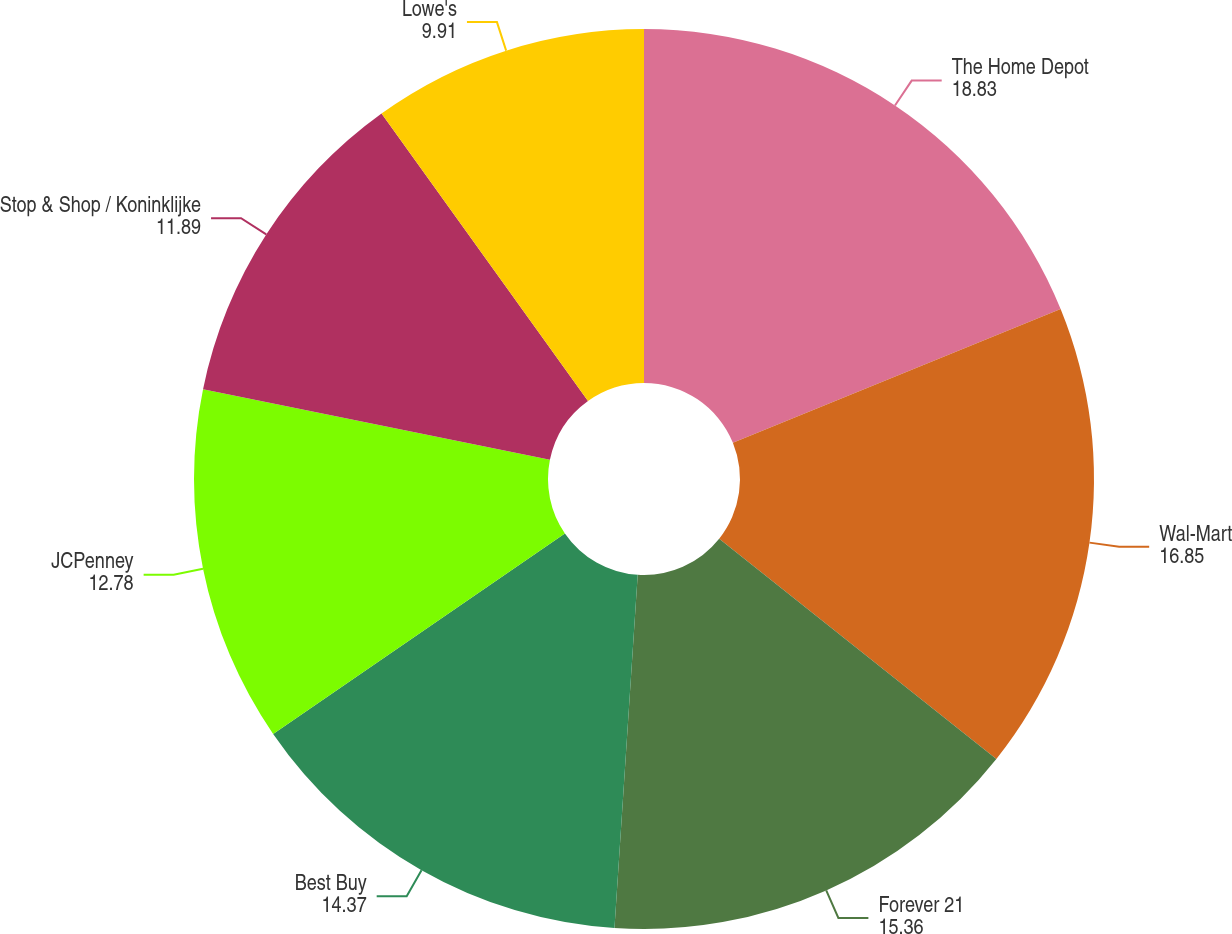Convert chart. <chart><loc_0><loc_0><loc_500><loc_500><pie_chart><fcel>The Home Depot<fcel>Wal-Mart<fcel>Forever 21<fcel>Best Buy<fcel>JCPenney<fcel>Stop & Shop / Koninklijke<fcel>Lowe's<nl><fcel>18.83%<fcel>16.85%<fcel>15.36%<fcel>14.37%<fcel>12.78%<fcel>11.89%<fcel>9.91%<nl></chart> 